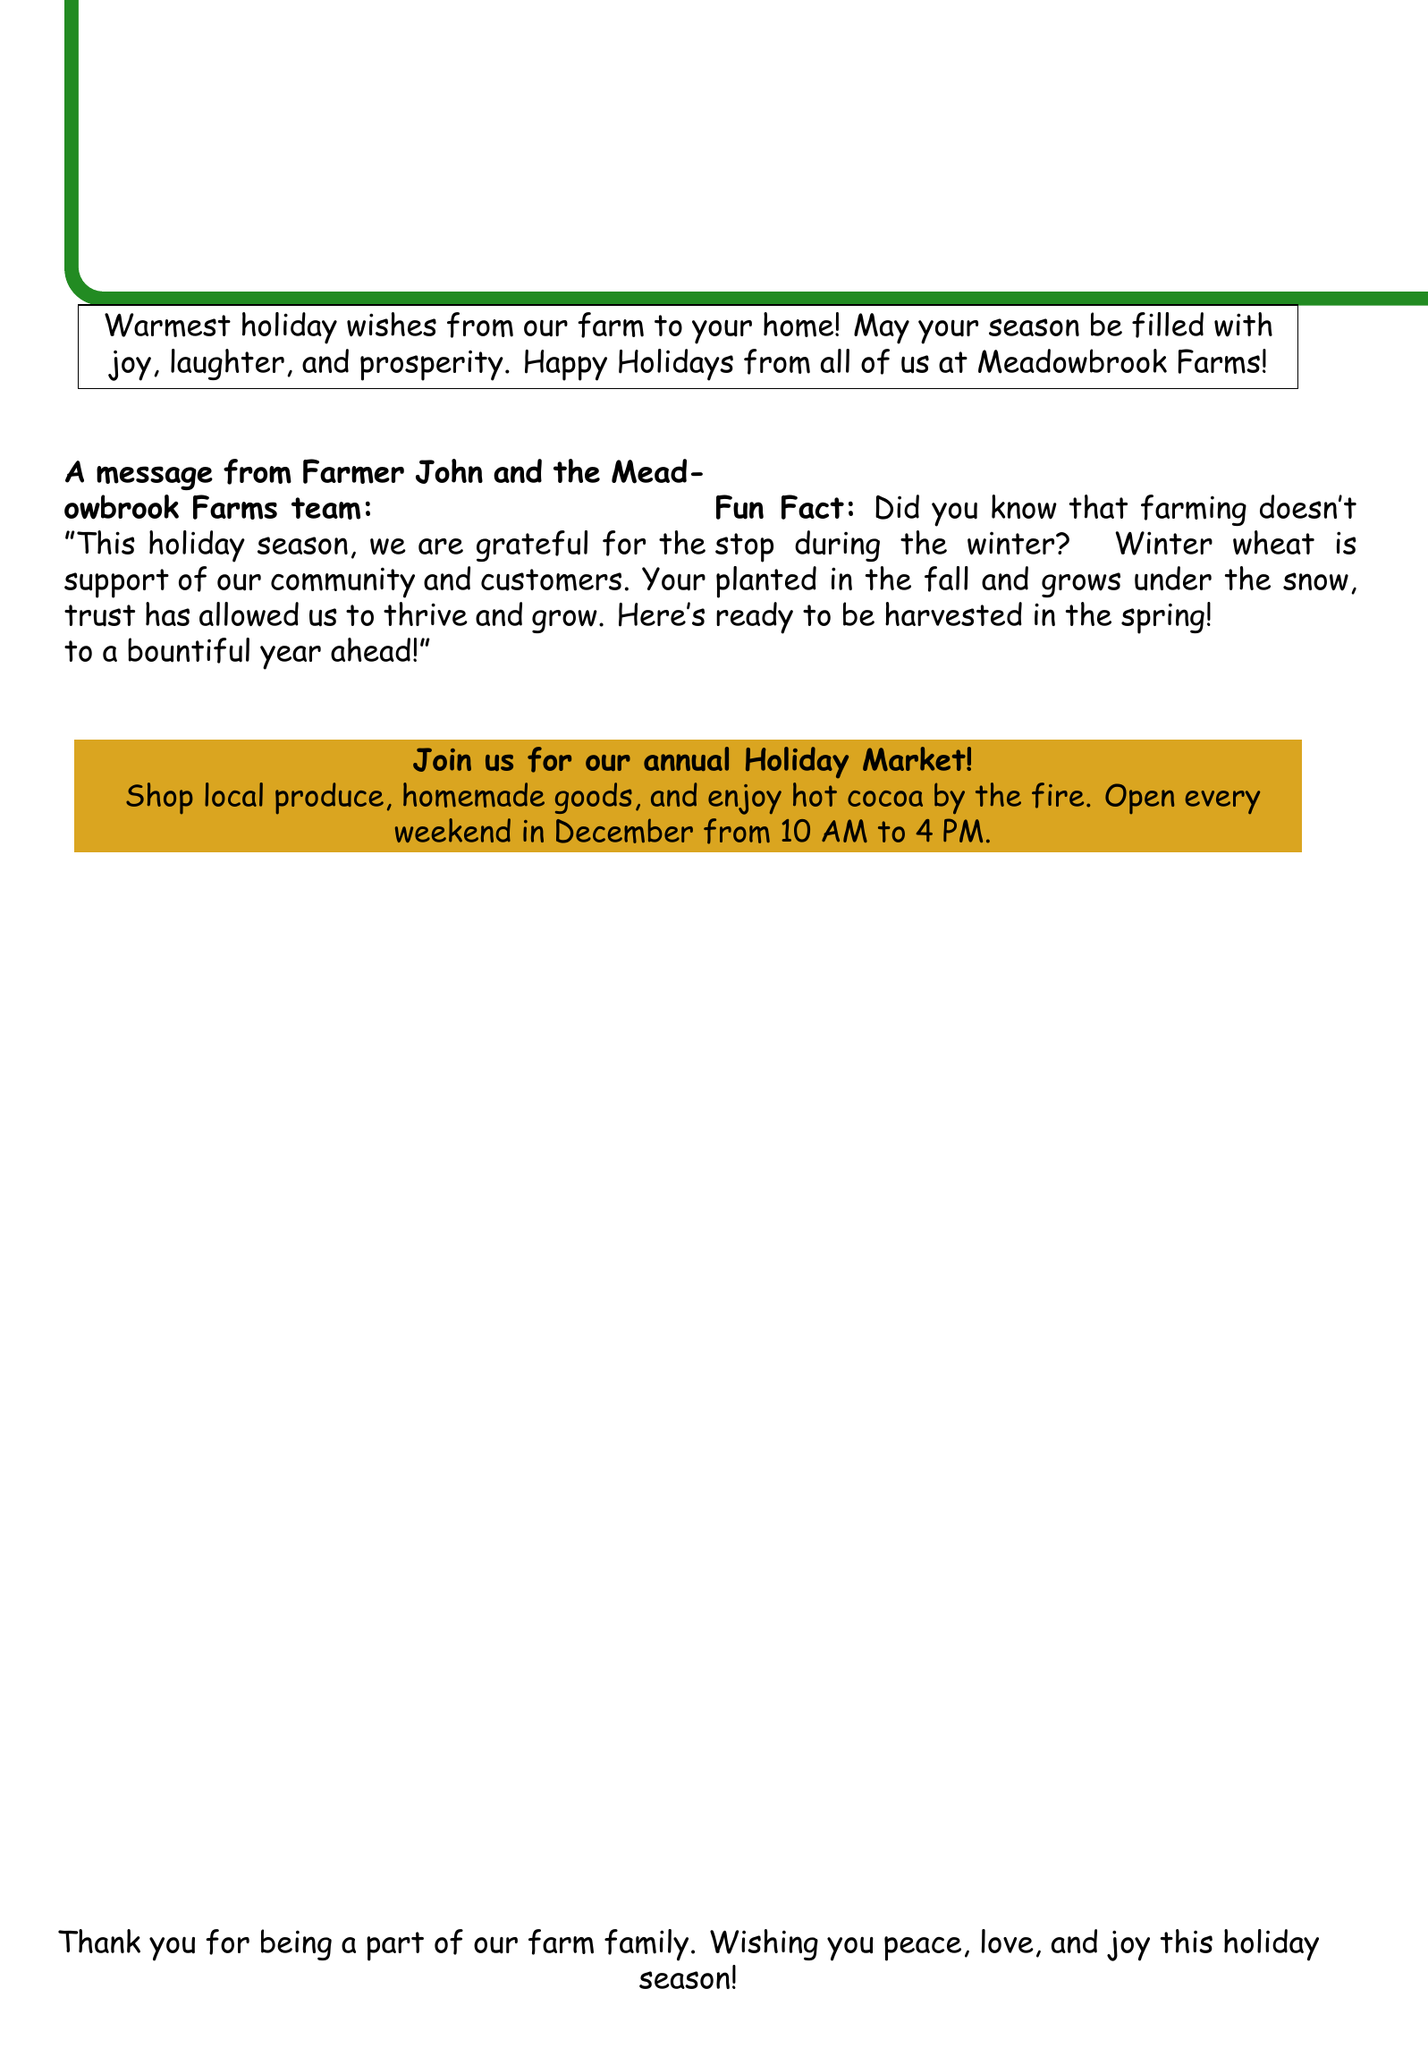What is the name of the farm? The name of the farm is mentioned in the greeting card as "Meadowbrook Farms."
Answer: Meadowbrook Farms Who is the message from? The message in the card is specifically stated to be from "Farmer John and the Meadowbrook Farms team."
Answer: Farmer John and the Meadowbrook Farms team What is the holiday greeting? The holiday greeting message can be found at the top of the card, providing warm wishes.
Answer: Happy Holidays from the Farm When is the Holiday Market open? The document specifies the operational hours for the Holiday Market in December.
Answer: Every weekend in December from 10 AM to 4 PM What is a fun fact mentioned? The document includes a fun fact about winter wheat that highlights farm activity during winter.
Answer: Winter wheat is planted in the fall What does the farm wish for its community? The closing message of the card expresses the farm's wishes for the community during the holiday season.
Answer: Peace, love, and joy What color is used for the holiday title? The color used for the title on the card is described within the document and is associated with the farm theme.
Answer: Farmgreen What is provided at the Holiday Market? The card mentions items that can be purchased or enjoyed at the Holiday Market.
Answer: Local produce, homemade goods, and hot cocoa What season is the greeting card themed around? The document reflects on a specific time of the year highlighted by the greeting.
Answer: Holiday season 